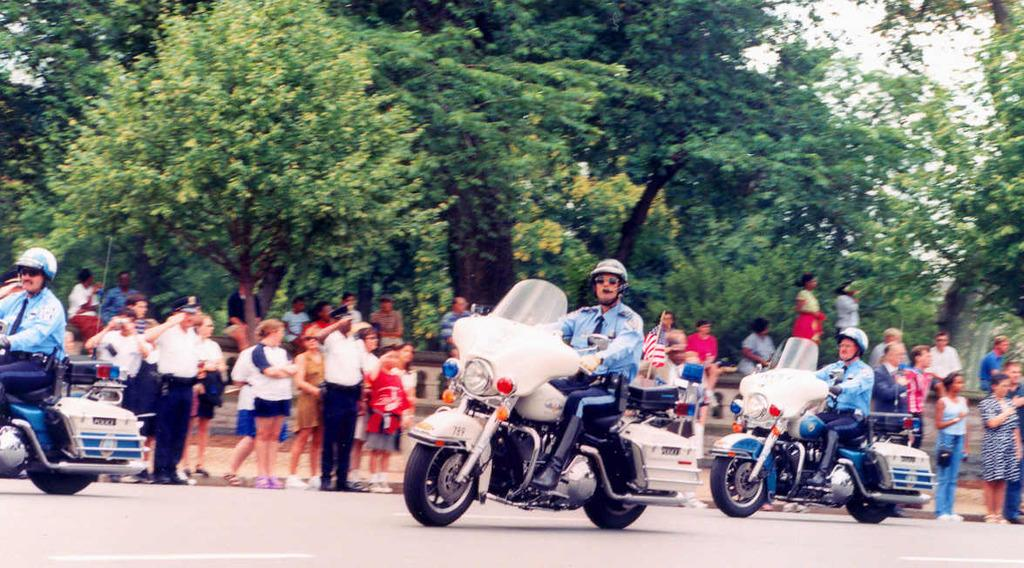How many men are in the image? There are 3 men in the image. What are the men doing in the image? The men are riding bikes on the road. What safety precaution are the men taking while riding their bikes? The men are wearing helmets. Are there any spectators in the image? Yes, there are people behind the men watching them. What can be seen in the background of the image? There are many trees visible in the background. What is the number of the discussion taking place between the men in the image? There is no discussion taking place between the men in the image; they are riding bikes. Can you tell me the name of the porter who is assisting the men in the image? There is no porter present in the image; the men are riding bikes on their own. 